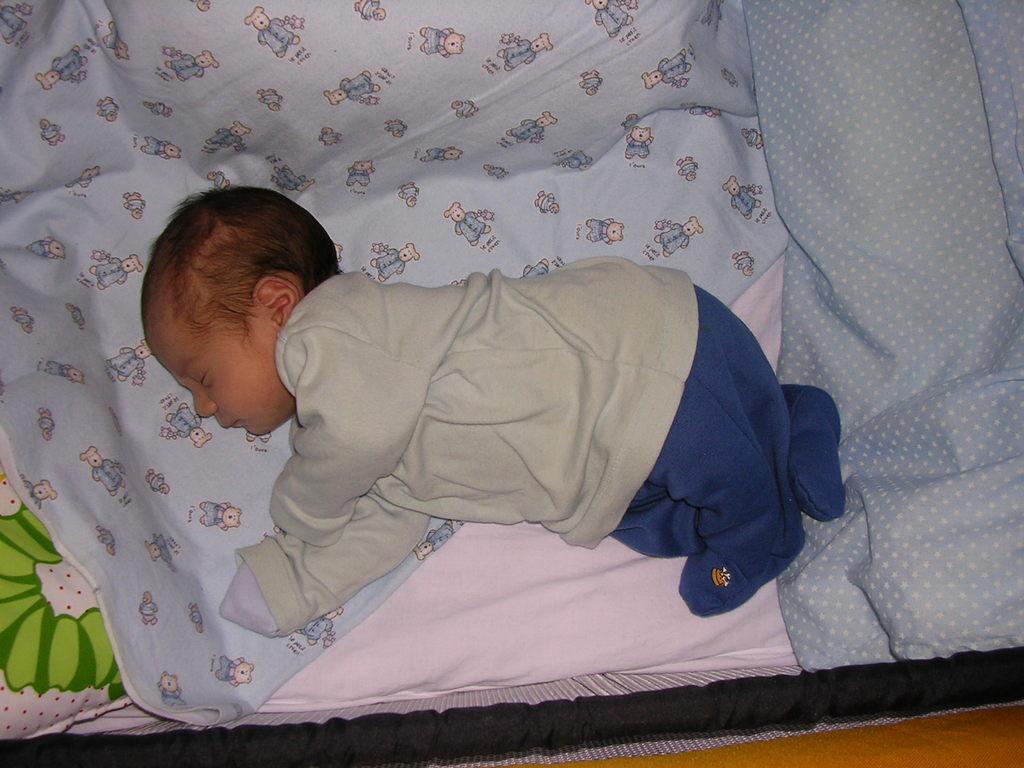In one or two sentences, can you explain what this image depicts? Here I can see a baby is laying on a bed sheet. On the bed sheet I can see few cartoon images. 